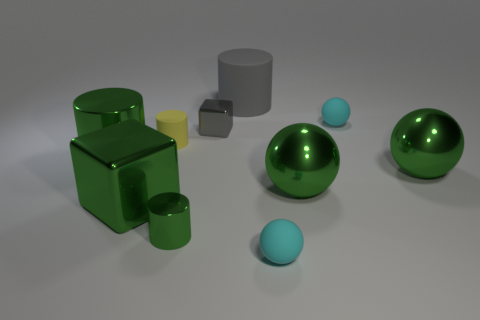Subtract all spheres. How many objects are left? 6 Subtract all big shiny spheres. Subtract all tiny green shiny objects. How many objects are left? 7 Add 9 large green blocks. How many large green blocks are left? 10 Add 3 large red matte spheres. How many large red matte spheres exist? 3 Subtract 0 blue cylinders. How many objects are left? 10 